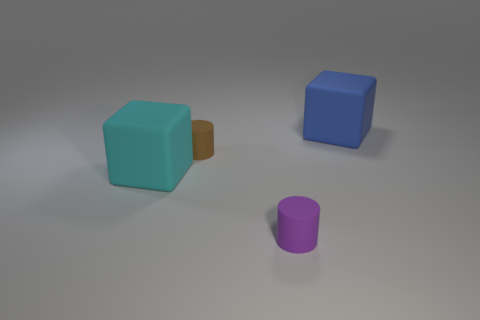Add 2 small brown cylinders. How many objects exist? 6 Subtract 1 blue blocks. How many objects are left? 3 Subtract all tiny cylinders. Subtract all cubes. How many objects are left? 0 Add 1 small purple rubber objects. How many small purple rubber objects are left? 2 Add 4 large blue matte cubes. How many large blue matte cubes exist? 5 